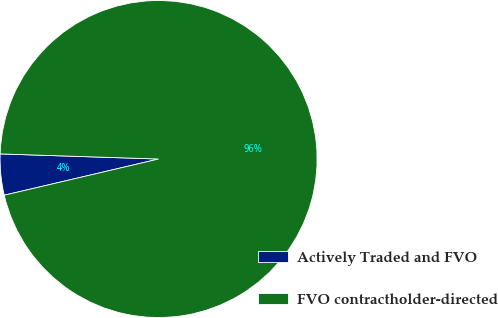Convert chart to OTSL. <chart><loc_0><loc_0><loc_500><loc_500><pie_chart><fcel>Actively Traded and FVO<fcel>FVO contractholder-directed<nl><fcel>4.18%<fcel>95.82%<nl></chart> 